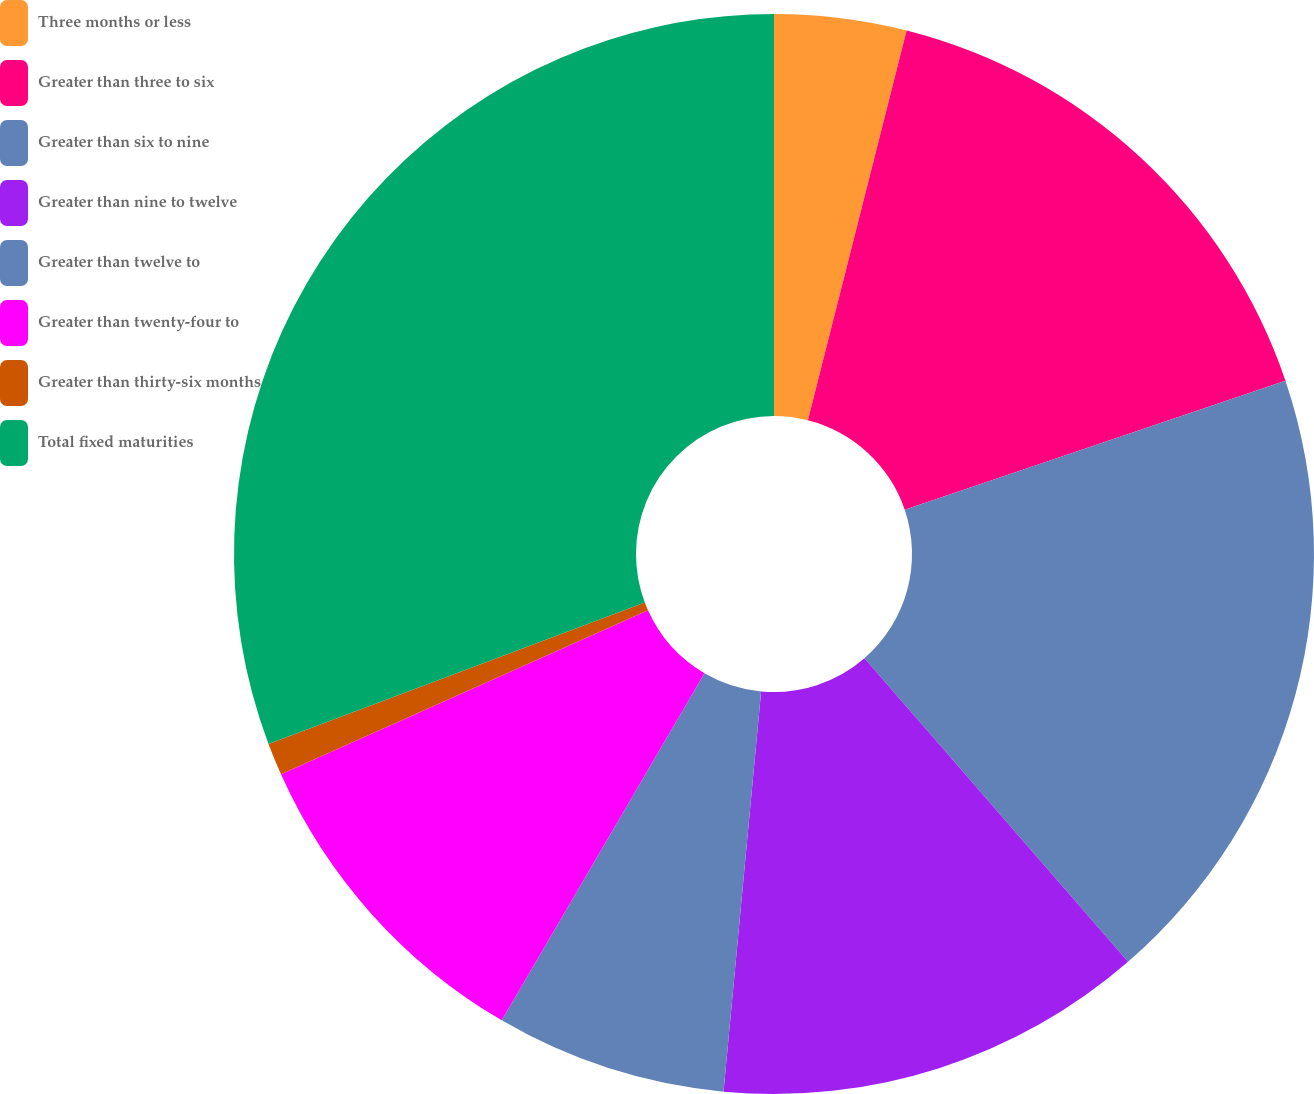Convert chart. <chart><loc_0><loc_0><loc_500><loc_500><pie_chart><fcel>Three months or less<fcel>Greater than three to six<fcel>Greater than six to nine<fcel>Greater than nine to twelve<fcel>Greater than twelve to<fcel>Greater than twenty-four to<fcel>Greater than thirty-six months<fcel>Total fixed maturities<nl><fcel>3.95%<fcel>15.85%<fcel>18.82%<fcel>12.87%<fcel>6.92%<fcel>9.9%<fcel>0.97%<fcel>30.72%<nl></chart> 